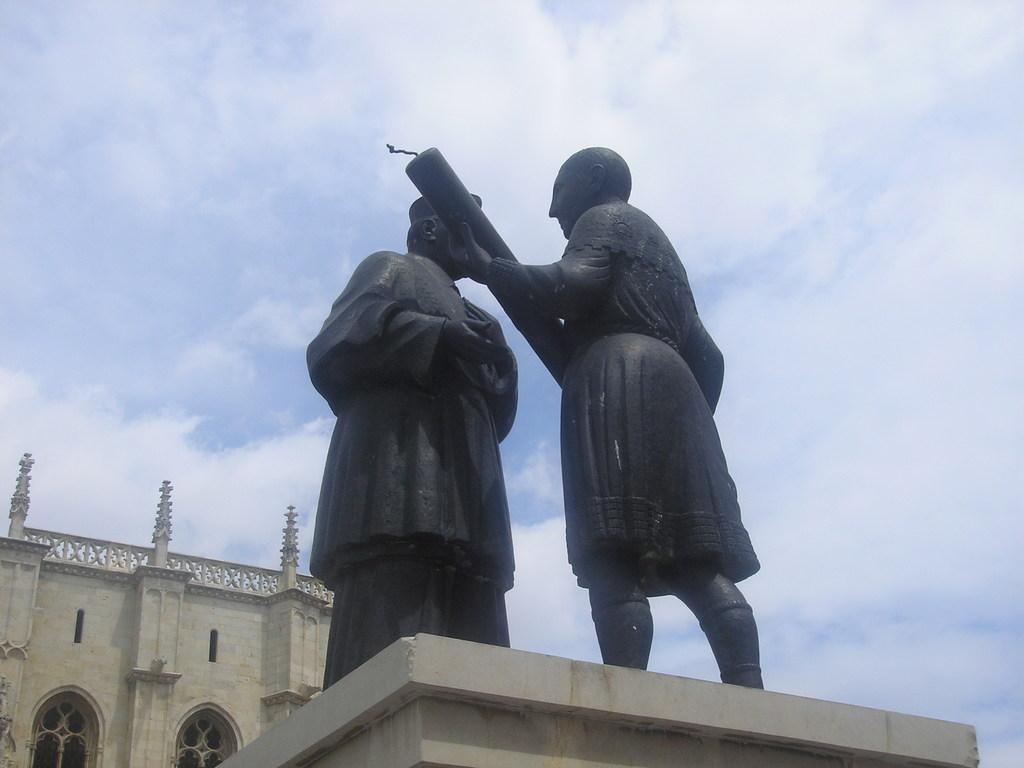How many statues are present in the image? There are two statues in the image. What can be seen in the background of the image? There is a building in the background of the image. What is the color of the building? The building is white in color. What is visible at the top of the image? The sky is visible at the top of the image. What type of lead is being used by the statues in the image? There are no leads present in the image, and the statues are not using any tools or materials. 